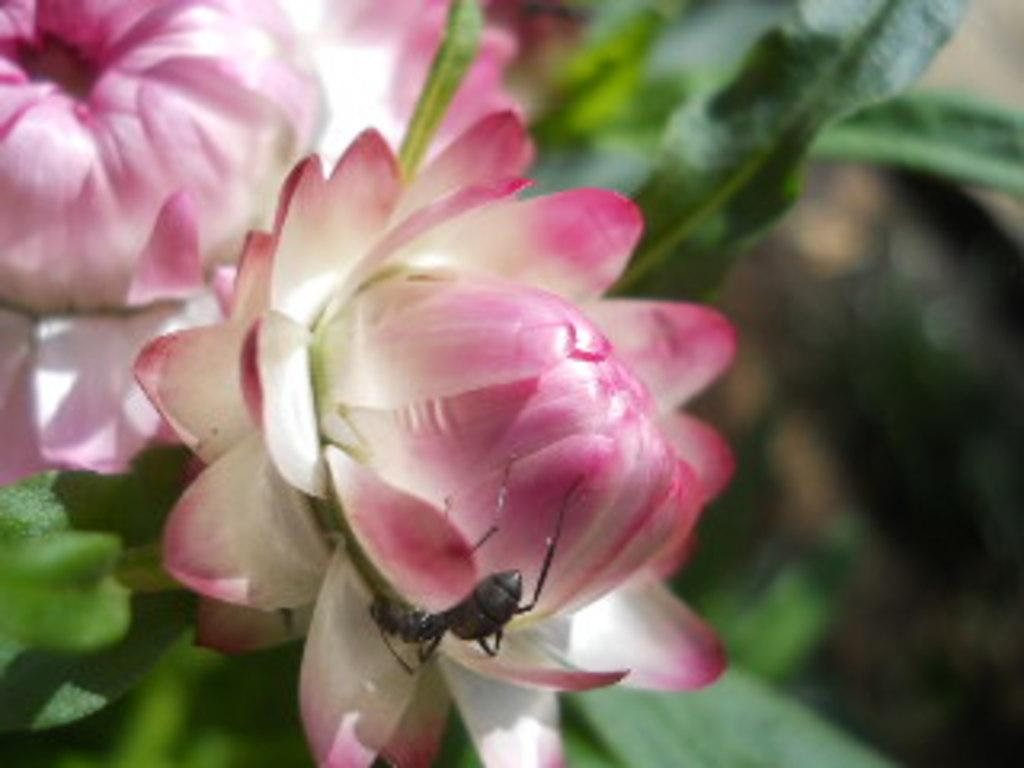What type of living organisms can be seen in the image? There are flowers in the image. Where are the flowers located? The flowers are on plants. What colors are the flowers? The flowers are in white and pink colors. Is there any other living organism interacting with the flowers? Yes, there is an insect on one of the flowers. How many sisters are present in the image? There are no sisters mentioned or depicted in the image. What type of pies can be seen in the image? There are no pies present in the image; it features flowers on plants. 